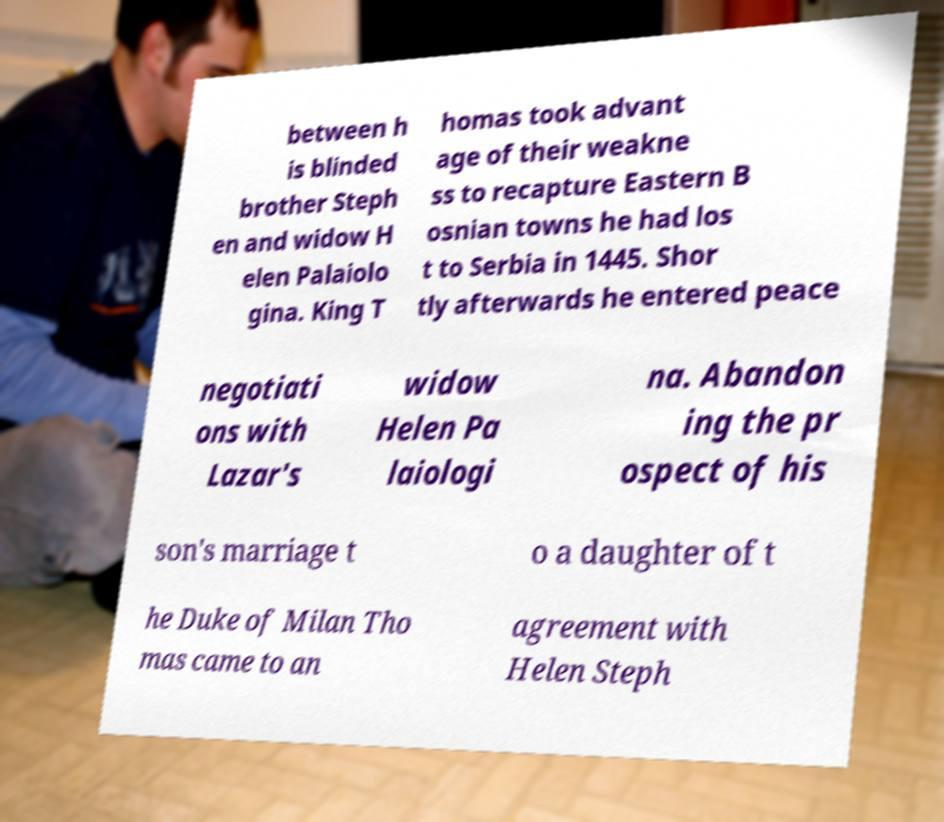For documentation purposes, I need the text within this image transcribed. Could you provide that? between h is blinded brother Steph en and widow H elen Palaiolo gina. King T homas took advant age of their weakne ss to recapture Eastern B osnian towns he had los t to Serbia in 1445. Shor tly afterwards he entered peace negotiati ons with Lazar's widow Helen Pa laiologi na. Abandon ing the pr ospect of his son's marriage t o a daughter of t he Duke of Milan Tho mas came to an agreement with Helen Steph 